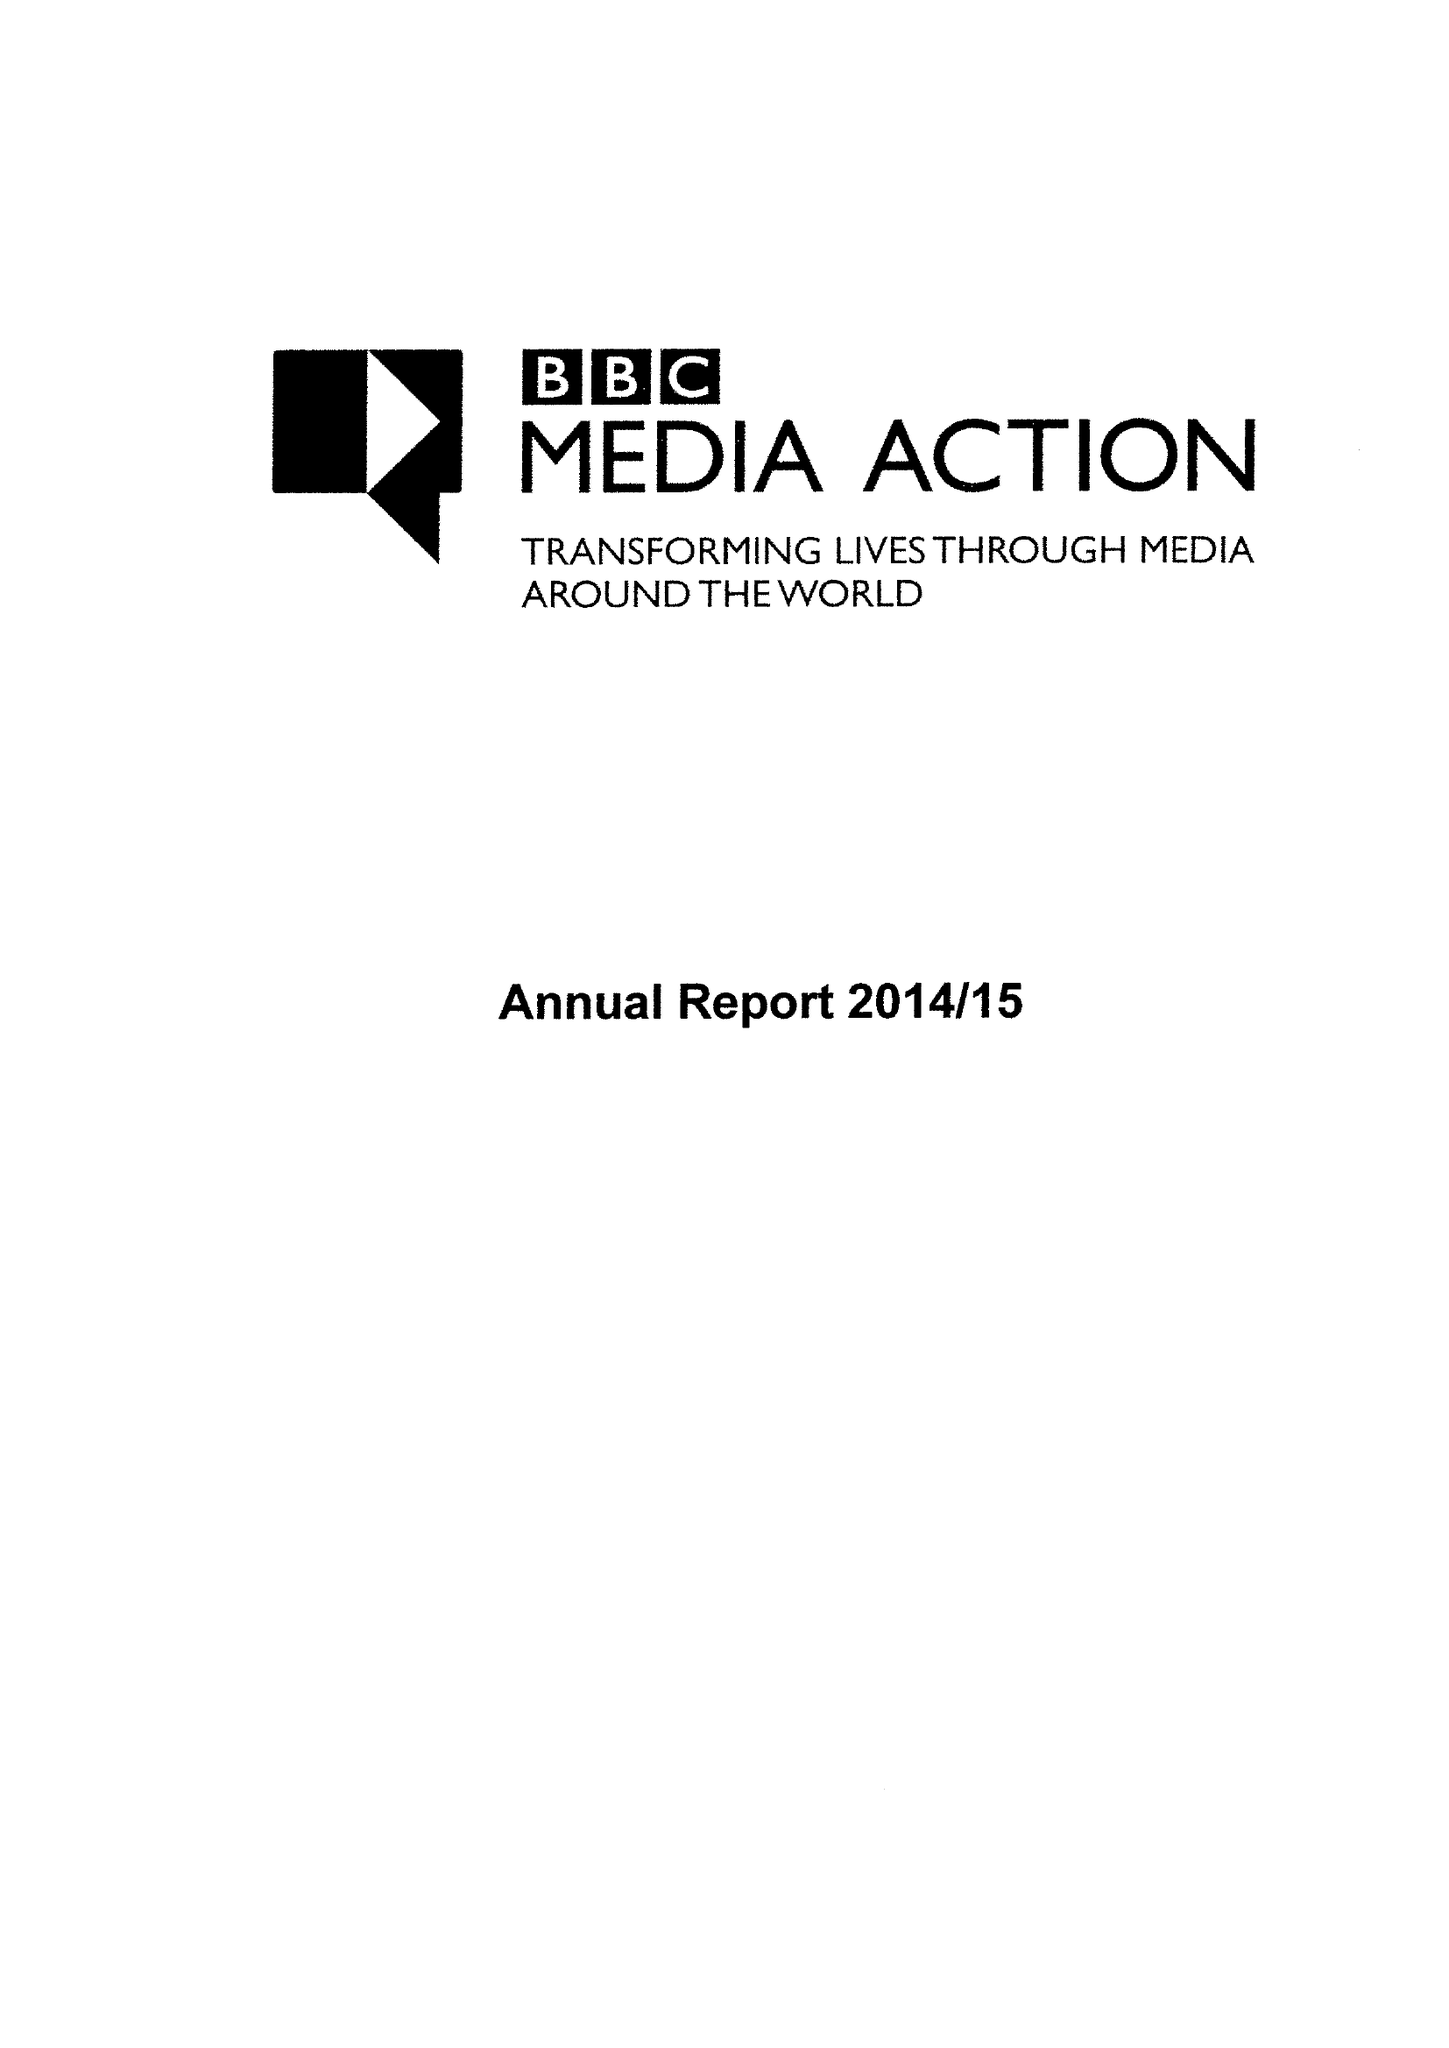What is the value for the spending_annually_in_british_pounds?
Answer the question using a single word or phrase. 46907000.00 